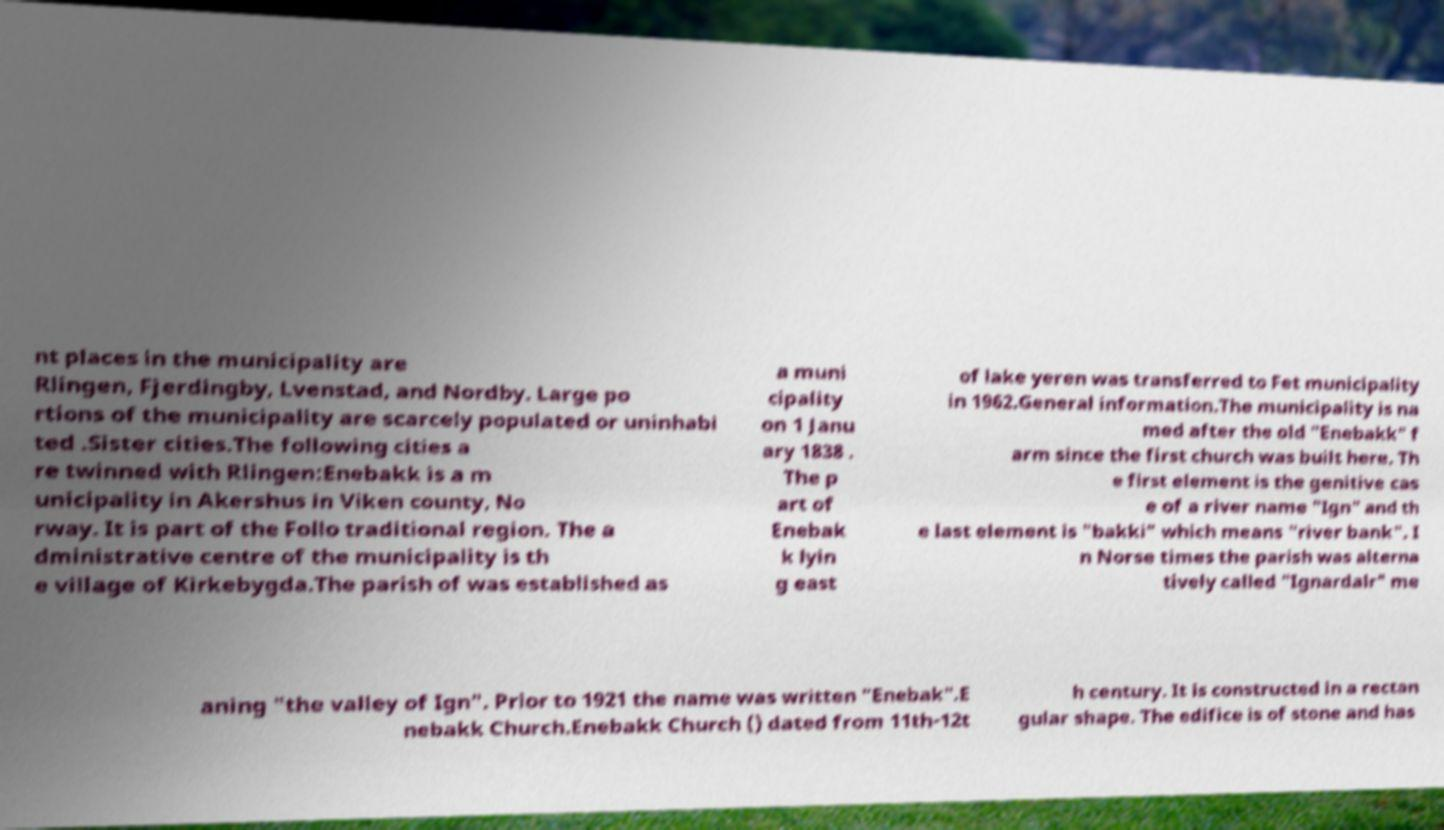I need the written content from this picture converted into text. Can you do that? nt places in the municipality are Rlingen, Fjerdingby, Lvenstad, and Nordby. Large po rtions of the municipality are scarcely populated or uninhabi ted .Sister cities.The following cities a re twinned with Rlingen:Enebakk is a m unicipality in Akershus in Viken county, No rway. It is part of the Follo traditional region. The a dministrative centre of the municipality is th e village of Kirkebygda.The parish of was established as a muni cipality on 1 Janu ary 1838 . The p art of Enebak k lyin g east of lake yeren was transferred to Fet municipality in 1962.General information.The municipality is na med after the old "Enebakk" f arm since the first church was built here. Th e first element is the genitive cas e of a river name "Ign" and th e last element is "bakki" which means "river bank". I n Norse times the parish was alterna tively called "Ignardalr" me aning "the valley of Ign". Prior to 1921 the name was written "Enebak".E nebakk Church.Enebakk Church () dated from 11th-12t h century. It is constructed in a rectan gular shape. The edifice is of stone and has 